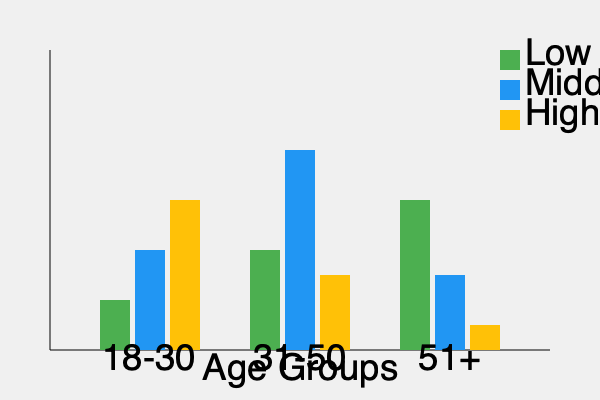Based on the clustered bar chart showing customer demographics by age and income level, which market segment presents the greatest opportunity for growth, and what strategy would you recommend to target this segment effectively? To answer this question, we need to analyze the data presented in the clustered bar chart and identify the most promising market segment. Let's break down the analysis step-by-step:

1. Examine the age groups:
   - 18-30
   - 31-50
   - 51+

2. Analyze the income levels for each age group:
   - Low Income (Green)
   - Middle Income (Blue)
   - High Income (Yellow)

3. Identify the largest segments:
   - The 31-50 age group has the highest percentage of middle-income customers.
   - The 51+ age group has the highest percentage of low-income customers.

4. Consider growth potential:
   - The 31-50 age group with middle income is already the largest segment, which may indicate market saturation.
   - The 18-30 age group shows a more balanced distribution across income levels, suggesting potential for growth.

5. Evaluate purchasing power and long-term value:
   - The 18-30 age group, particularly the middle and high-income segments, have significant purchasing power and the potential for long-term customer relationships.

6. Recommend a strategy:
   - Target the 18-30 age group, focusing on middle and high-income segments.
   - Develop products and services that appeal to young professionals and emerging affluent customers.
   - Implement a digital-first marketing approach, utilizing social media and mobile platforms.
   - Offer personalized experiences and loyalty programs to build long-term relationships.
   - Create aspirational branding that resonates with this demographic's lifestyle and values.

Based on this analysis, the 18-30 age group, particularly the middle and high-income segments, presents the greatest opportunity for growth. This segment has a balanced distribution across income levels, suggesting room for expansion, and offers the potential for long-term customer value.
Answer: Target 18-30 age group, focus on middle and high-income segments with digital-first marketing, personalized experiences, and aspirational branding. 